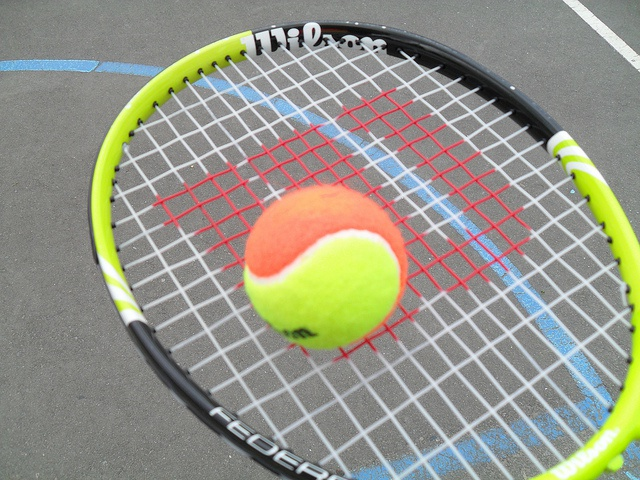Describe the objects in this image and their specific colors. I can see tennis racket in gray, lightgray, and yellow tones and sports ball in gray, salmon, yellow, and khaki tones in this image. 